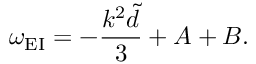<formula> <loc_0><loc_0><loc_500><loc_500>\omega _ { E I } = - \frac { k ^ { 2 } \widetilde { d } } { 3 } + A + B .</formula> 